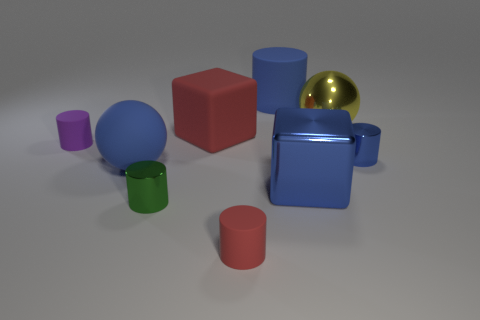Does the large red object have the same shape as the tiny matte object to the left of the tiny green cylinder?
Make the answer very short. No. Are there any tiny red things on the left side of the blue ball?
Your answer should be compact. No. There is a tiny object that is the same color as the large cylinder; what is its material?
Your response must be concise. Metal. Does the yellow sphere have the same size as the rubber cylinder that is to the left of the large red rubber cube?
Your answer should be compact. No. Are there any matte cylinders of the same color as the large shiny cube?
Keep it short and to the point. Yes. Are there any other things that have the same shape as the small red object?
Your answer should be compact. Yes. There is a big thing that is both right of the big matte block and in front of the rubber cube; what is its shape?
Give a very brief answer. Cube. What number of big yellow objects have the same material as the tiny green object?
Offer a very short reply. 1. Are there fewer small green objects on the right side of the big blue matte cylinder than tiny cyan rubber balls?
Give a very brief answer. No. Are there any big cubes in front of the ball that is right of the tiny green thing?
Your response must be concise. Yes. 